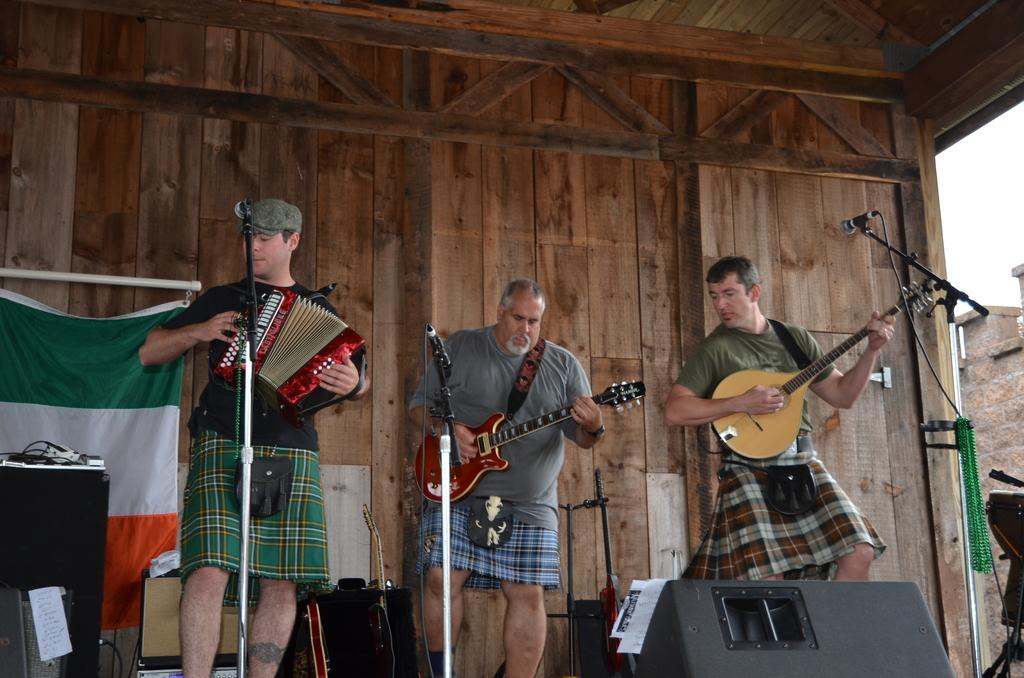How many people are in the image? There are people in the image, but the exact number is not specified. What are the people doing in the image? The people are standing in the image. What are the people holding in their hands? The people are holding musical instruments in their hands. What type of rifle can be seen in the hands of the people in the image? There is no rifle present in the image; the people are holding musical instruments. What show are the people attending in the image? There is no indication of a show or event in the image; the people are simply standing and holding musical instruments. 